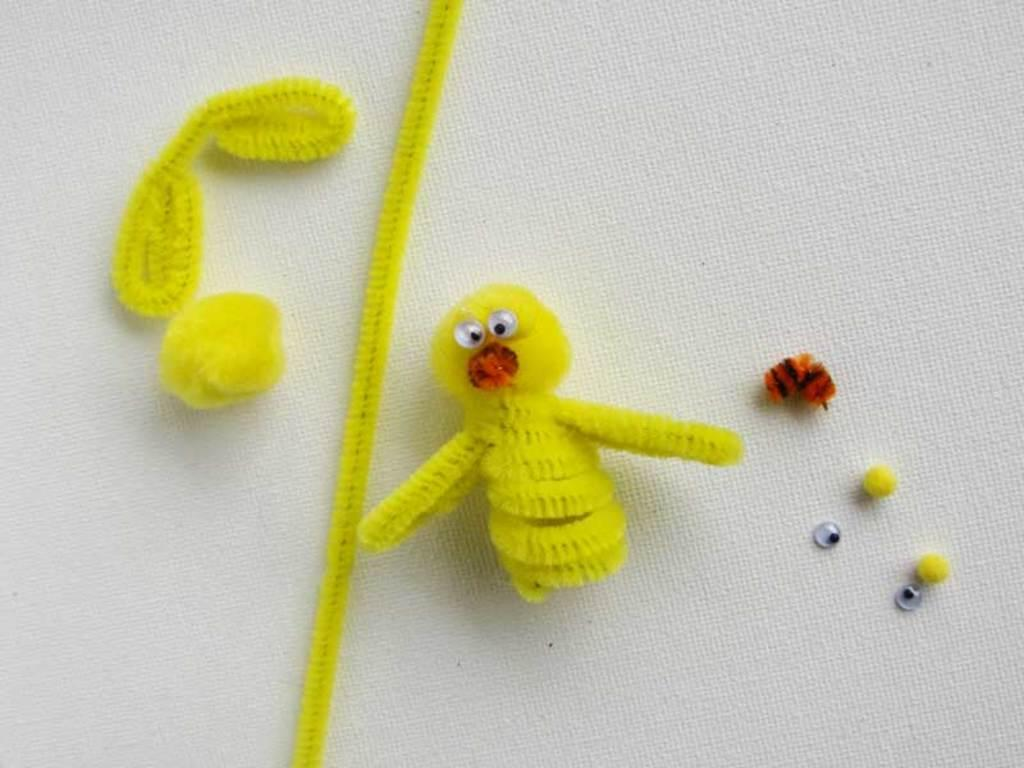What is the main subject in the image? There is a craft in the image. What is the craft placed on? The craft is on a white color cloth. What type of sponge is used to create the craft in the image? There is no information about the materials used to create the craft in the image, and no sponge is mentioned or visible. 